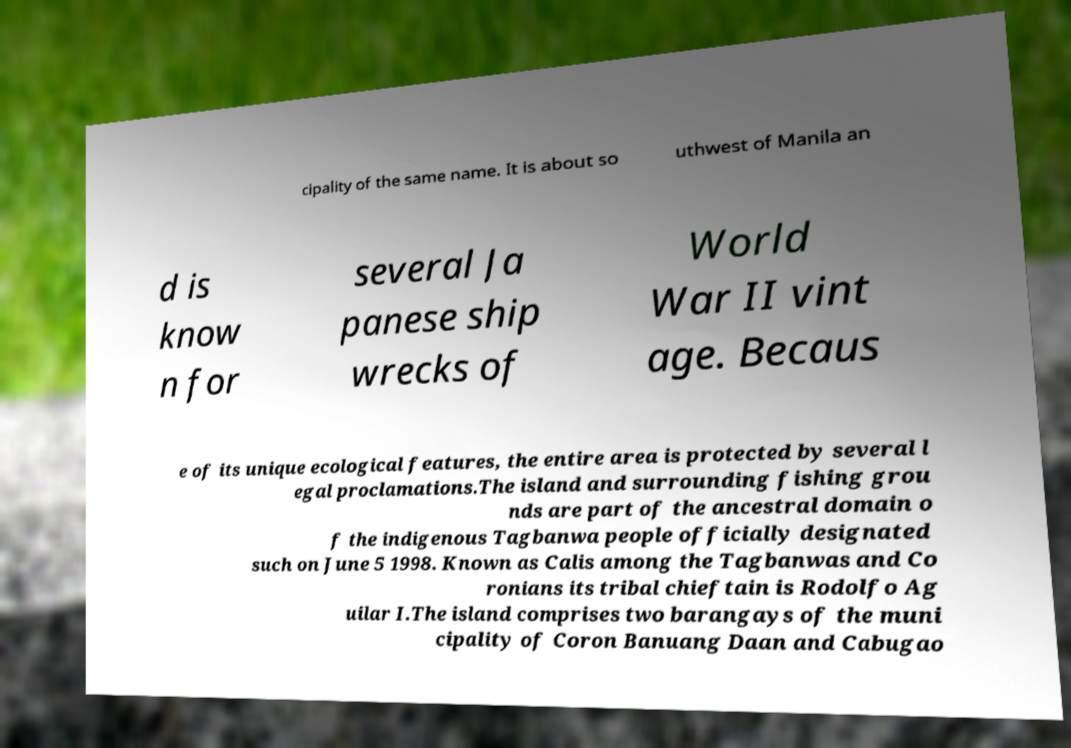For documentation purposes, I need the text within this image transcribed. Could you provide that? cipality of the same name. It is about so uthwest of Manila an d is know n for several Ja panese ship wrecks of World War II vint age. Becaus e of its unique ecological features, the entire area is protected by several l egal proclamations.The island and surrounding fishing grou nds are part of the ancestral domain o f the indigenous Tagbanwa people officially designated such on June 5 1998. Known as Calis among the Tagbanwas and Co ronians its tribal chieftain is Rodolfo Ag uilar I.The island comprises two barangays of the muni cipality of Coron Banuang Daan and Cabugao 